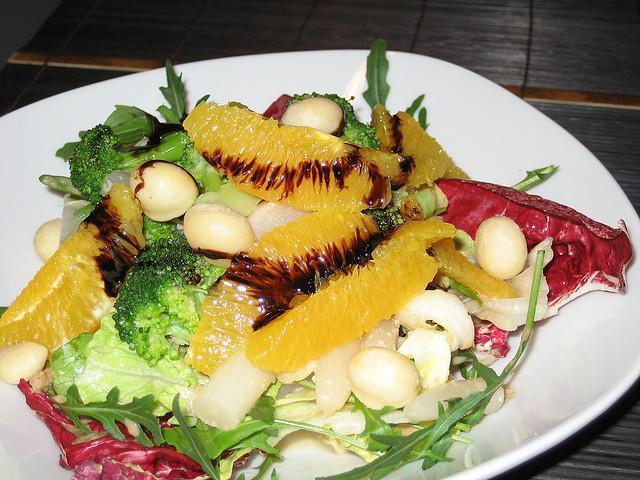How many broccolis can you see?
Give a very brief answer. 2. How many oranges are there?
Give a very brief answer. 5. 